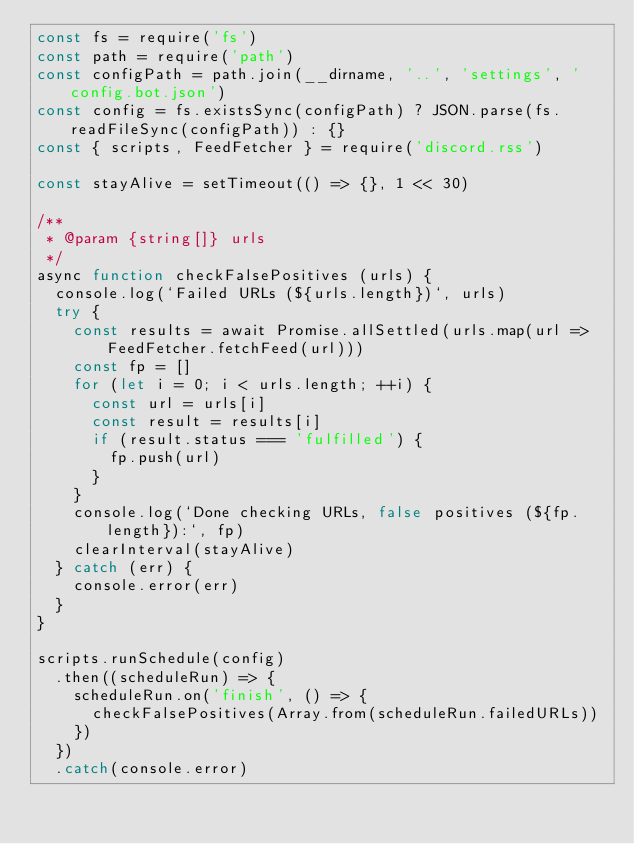<code> <loc_0><loc_0><loc_500><loc_500><_JavaScript_>const fs = require('fs')
const path = require('path')
const configPath = path.join(__dirname, '..', 'settings', 'config.bot.json')
const config = fs.existsSync(configPath) ? JSON.parse(fs.readFileSync(configPath)) : {}
const { scripts, FeedFetcher } = require('discord.rss')

const stayAlive = setTimeout(() => {}, 1 << 30)

/**
 * @param {string[]} urls 
 */
async function checkFalsePositives (urls) {
  console.log(`Failed URLs (${urls.length})`, urls)
  try {
    const results = await Promise.allSettled(urls.map(url => FeedFetcher.fetchFeed(url)))
    const fp = []
    for (let i = 0; i < urls.length; ++i) {
      const url = urls[i]
      const result = results[i]
      if (result.status === 'fulfilled') {
        fp.push(url)
      }
    }
    console.log(`Done checking URLs, false positives (${fp.length}):`, fp)
    clearInterval(stayAlive)
  } catch (err) {
    console.error(err)
  }
}

scripts.runSchedule(config)
  .then((scheduleRun) => {
    scheduleRun.on('finish', () => {
      checkFalsePositives(Array.from(scheduleRun.failedURLs))
    })
  })
  .catch(console.error)
</code> 